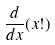<formula> <loc_0><loc_0><loc_500><loc_500>\frac { d } { d x } ( x ! )</formula> 